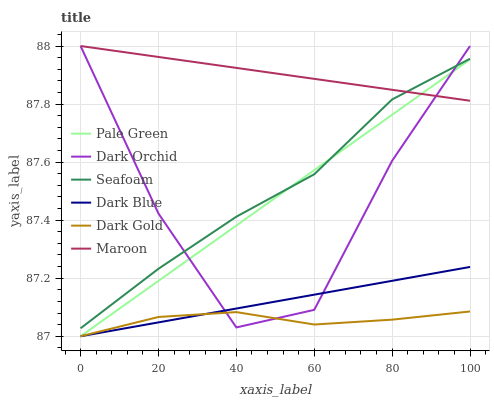Does Dark Gold have the minimum area under the curve?
Answer yes or no. Yes. Does Maroon have the maximum area under the curve?
Answer yes or no. Yes. Does Seafoam have the minimum area under the curve?
Answer yes or no. No. Does Seafoam have the maximum area under the curve?
Answer yes or no. No. Is Dark Blue the smoothest?
Answer yes or no. Yes. Is Dark Orchid the roughest?
Answer yes or no. Yes. Is Seafoam the smoothest?
Answer yes or no. No. Is Seafoam the roughest?
Answer yes or no. No. Does Seafoam have the lowest value?
Answer yes or no. No. Does Dark Orchid have the highest value?
Answer yes or no. Yes. Does Seafoam have the highest value?
Answer yes or no. No. Is Dark Gold less than Maroon?
Answer yes or no. Yes. Is Seafoam greater than Dark Gold?
Answer yes or no. Yes. Does Dark Gold intersect Dark Blue?
Answer yes or no. Yes. Is Dark Gold less than Dark Blue?
Answer yes or no. No. Is Dark Gold greater than Dark Blue?
Answer yes or no. No. Does Dark Gold intersect Maroon?
Answer yes or no. No. 